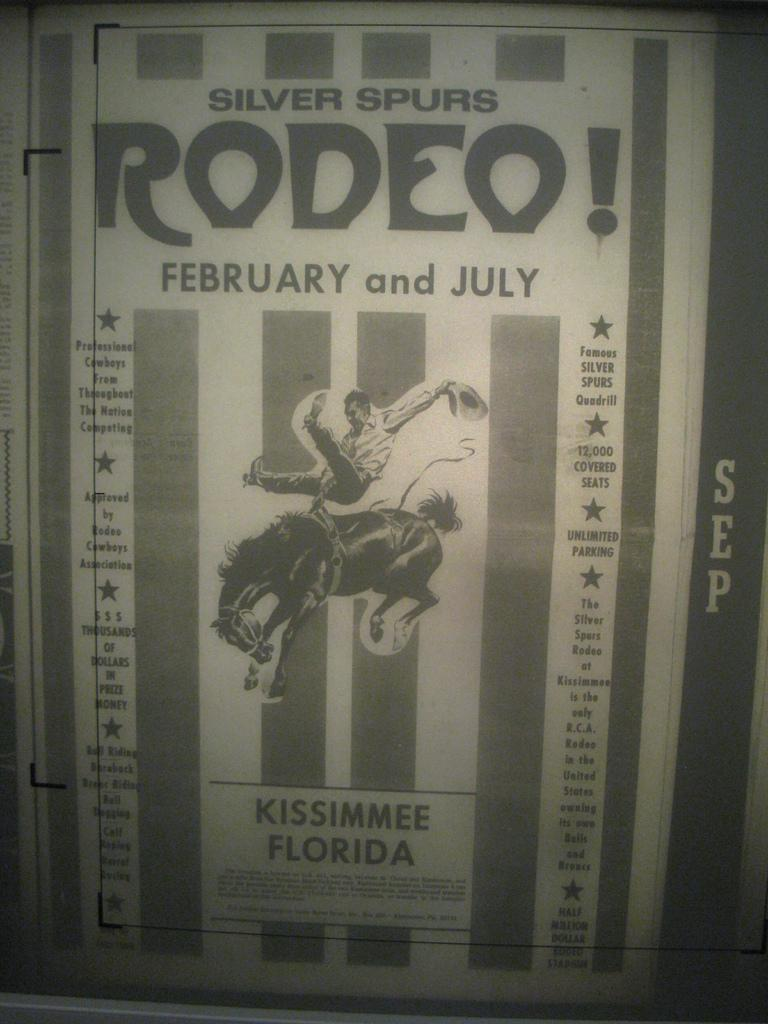<image>
Share a concise interpretation of the image provided. a poster that has rodeo written on it 